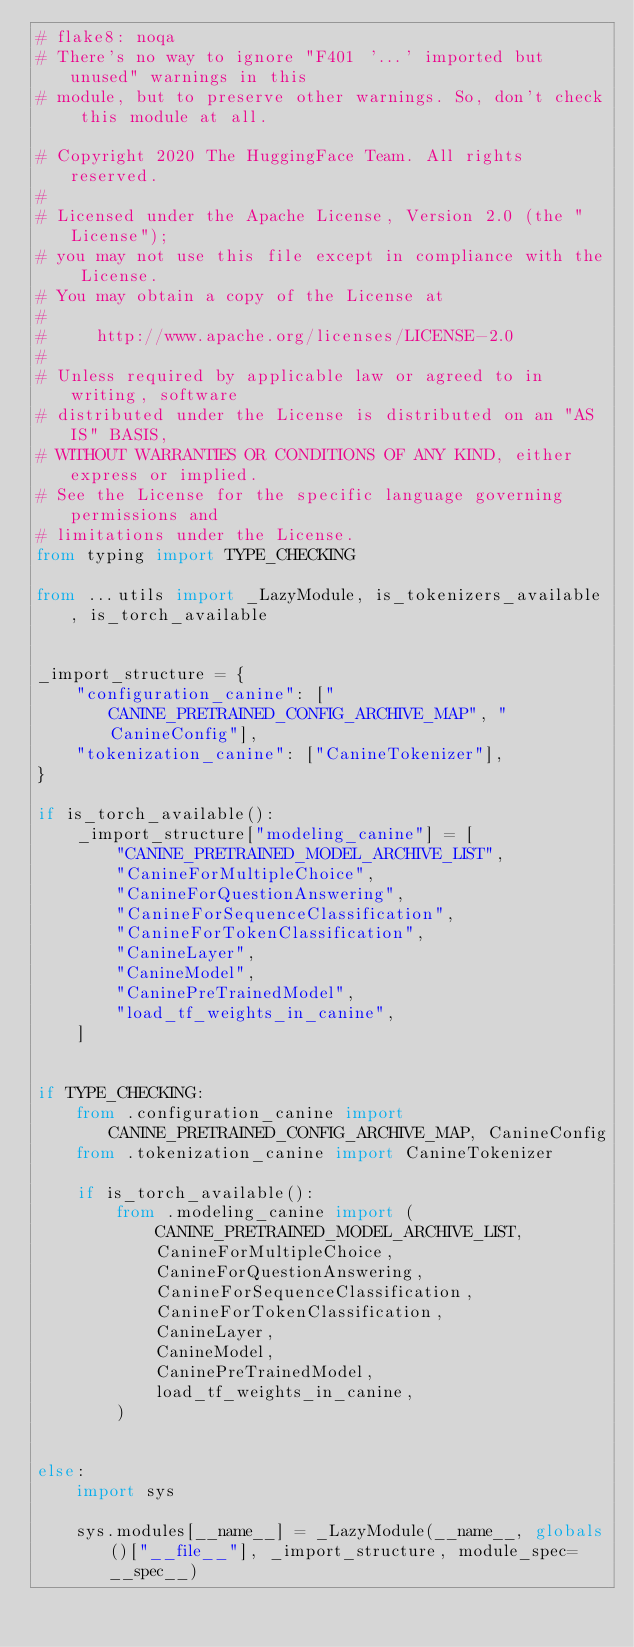Convert code to text. <code><loc_0><loc_0><loc_500><loc_500><_Python_># flake8: noqa
# There's no way to ignore "F401 '...' imported but unused" warnings in this
# module, but to preserve other warnings. So, don't check this module at all.

# Copyright 2020 The HuggingFace Team. All rights reserved.
#
# Licensed under the Apache License, Version 2.0 (the "License");
# you may not use this file except in compliance with the License.
# You may obtain a copy of the License at
#
#     http://www.apache.org/licenses/LICENSE-2.0
#
# Unless required by applicable law or agreed to in writing, software
# distributed under the License is distributed on an "AS IS" BASIS,
# WITHOUT WARRANTIES OR CONDITIONS OF ANY KIND, either express or implied.
# See the License for the specific language governing permissions and
# limitations under the License.
from typing import TYPE_CHECKING

from ...utils import _LazyModule, is_tokenizers_available, is_torch_available


_import_structure = {
    "configuration_canine": ["CANINE_PRETRAINED_CONFIG_ARCHIVE_MAP", "CanineConfig"],
    "tokenization_canine": ["CanineTokenizer"],
}

if is_torch_available():
    _import_structure["modeling_canine"] = [
        "CANINE_PRETRAINED_MODEL_ARCHIVE_LIST",
        "CanineForMultipleChoice",
        "CanineForQuestionAnswering",
        "CanineForSequenceClassification",
        "CanineForTokenClassification",
        "CanineLayer",
        "CanineModel",
        "CaninePreTrainedModel",
        "load_tf_weights_in_canine",
    ]


if TYPE_CHECKING:
    from .configuration_canine import CANINE_PRETRAINED_CONFIG_ARCHIVE_MAP, CanineConfig
    from .tokenization_canine import CanineTokenizer

    if is_torch_available():
        from .modeling_canine import (
            CANINE_PRETRAINED_MODEL_ARCHIVE_LIST,
            CanineForMultipleChoice,
            CanineForQuestionAnswering,
            CanineForSequenceClassification,
            CanineForTokenClassification,
            CanineLayer,
            CanineModel,
            CaninePreTrainedModel,
            load_tf_weights_in_canine,
        )


else:
    import sys

    sys.modules[__name__] = _LazyModule(__name__, globals()["__file__"], _import_structure, module_spec=__spec__)
</code> 